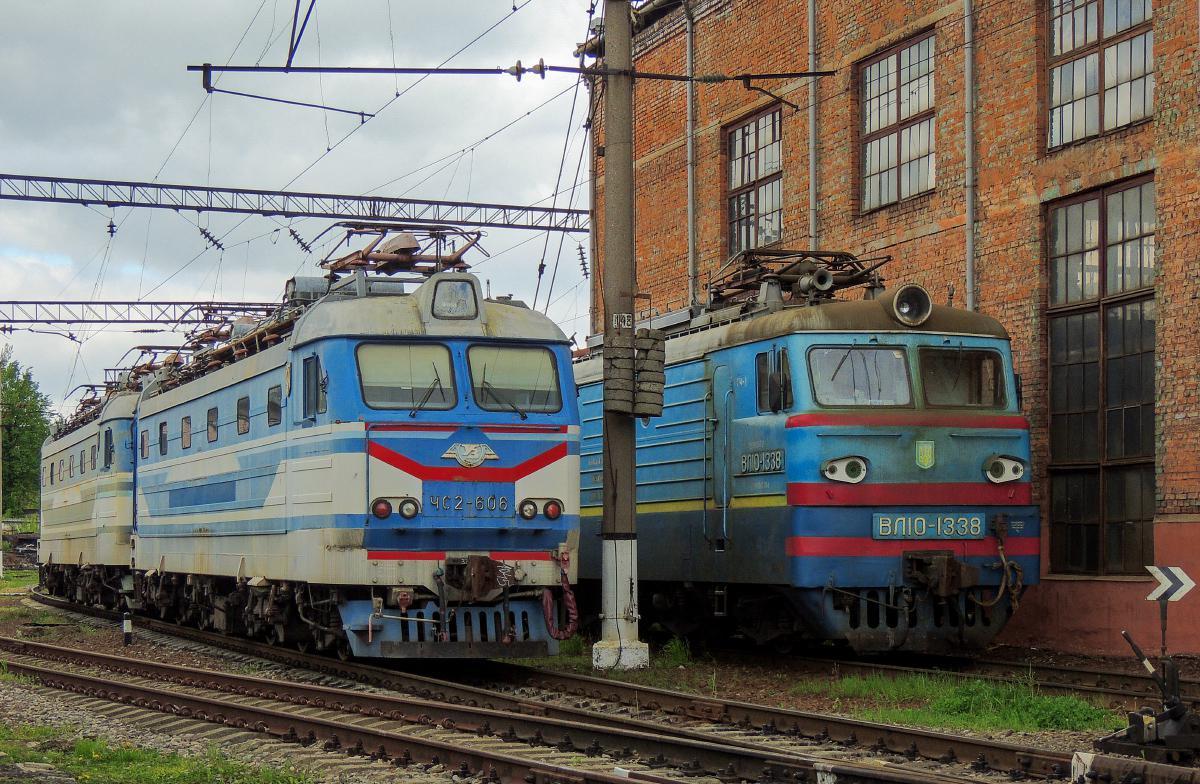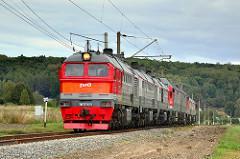The first image is the image on the left, the second image is the image on the right. Analyze the images presented: Is the assertion "All of the trains are facing to the right." valid? Answer yes or no. No. The first image is the image on the left, the second image is the image on the right. Examine the images to the left and right. Is the description "the right side image has a train heading to the left direction" accurate? Answer yes or no. Yes. 